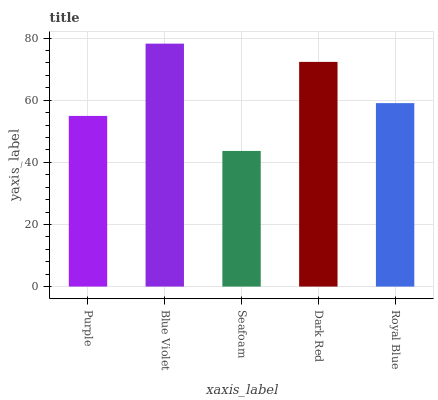Is Seafoam the minimum?
Answer yes or no. Yes. Is Blue Violet the maximum?
Answer yes or no. Yes. Is Blue Violet the minimum?
Answer yes or no. No. Is Seafoam the maximum?
Answer yes or no. No. Is Blue Violet greater than Seafoam?
Answer yes or no. Yes. Is Seafoam less than Blue Violet?
Answer yes or no. Yes. Is Seafoam greater than Blue Violet?
Answer yes or no. No. Is Blue Violet less than Seafoam?
Answer yes or no. No. Is Royal Blue the high median?
Answer yes or no. Yes. Is Royal Blue the low median?
Answer yes or no. Yes. Is Purple the high median?
Answer yes or no. No. Is Purple the low median?
Answer yes or no. No. 